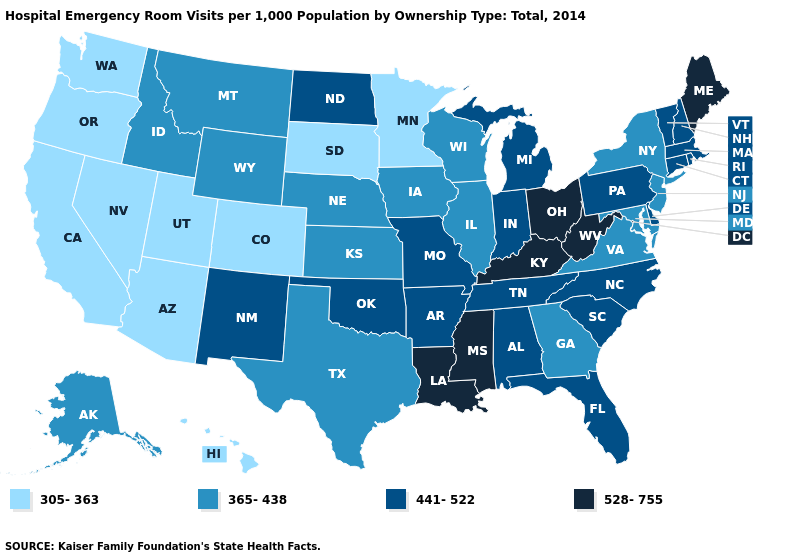Name the states that have a value in the range 441-522?
Be succinct. Alabama, Arkansas, Connecticut, Delaware, Florida, Indiana, Massachusetts, Michigan, Missouri, New Hampshire, New Mexico, North Carolina, North Dakota, Oklahoma, Pennsylvania, Rhode Island, South Carolina, Tennessee, Vermont. Which states hav the highest value in the MidWest?
Answer briefly. Ohio. What is the highest value in the MidWest ?
Concise answer only. 528-755. Does Pennsylvania have a higher value than Iowa?
Quick response, please. Yes. Name the states that have a value in the range 365-438?
Write a very short answer. Alaska, Georgia, Idaho, Illinois, Iowa, Kansas, Maryland, Montana, Nebraska, New Jersey, New York, Texas, Virginia, Wisconsin, Wyoming. What is the highest value in the USA?
Short answer required. 528-755. Does South Carolina have the lowest value in the South?
Be succinct. No. Name the states that have a value in the range 441-522?
Concise answer only. Alabama, Arkansas, Connecticut, Delaware, Florida, Indiana, Massachusetts, Michigan, Missouri, New Hampshire, New Mexico, North Carolina, North Dakota, Oklahoma, Pennsylvania, Rhode Island, South Carolina, Tennessee, Vermont. Does the map have missing data?
Write a very short answer. No. Name the states that have a value in the range 305-363?
Short answer required. Arizona, California, Colorado, Hawaii, Minnesota, Nevada, Oregon, South Dakota, Utah, Washington. Name the states that have a value in the range 441-522?
Concise answer only. Alabama, Arkansas, Connecticut, Delaware, Florida, Indiana, Massachusetts, Michigan, Missouri, New Hampshire, New Mexico, North Carolina, North Dakota, Oklahoma, Pennsylvania, Rhode Island, South Carolina, Tennessee, Vermont. Name the states that have a value in the range 365-438?
Be succinct. Alaska, Georgia, Idaho, Illinois, Iowa, Kansas, Maryland, Montana, Nebraska, New Jersey, New York, Texas, Virginia, Wisconsin, Wyoming. What is the value of Wyoming?
Answer briefly. 365-438. Name the states that have a value in the range 528-755?
Write a very short answer. Kentucky, Louisiana, Maine, Mississippi, Ohio, West Virginia. 